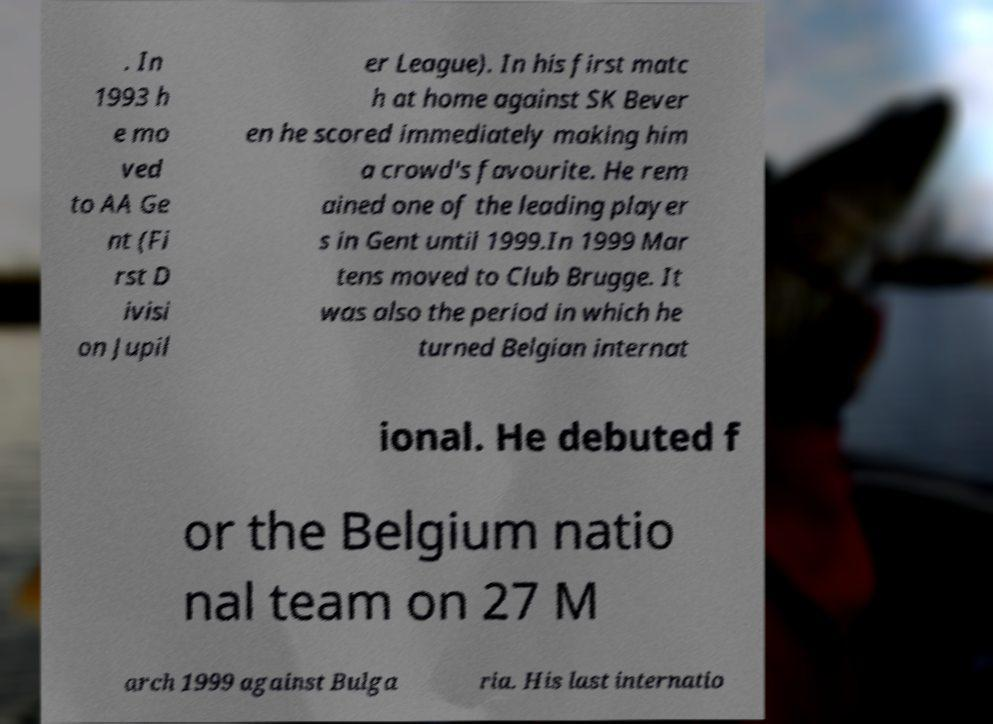What messages or text are displayed in this image? I need them in a readable, typed format. . In 1993 h e mo ved to AA Ge nt (Fi rst D ivisi on Jupil er League). In his first matc h at home against SK Bever en he scored immediately making him a crowd's favourite. He rem ained one of the leading player s in Gent until 1999.In 1999 Mar tens moved to Club Brugge. It was also the period in which he turned Belgian internat ional. He debuted f or the Belgium natio nal team on 27 M arch 1999 against Bulga ria. His last internatio 